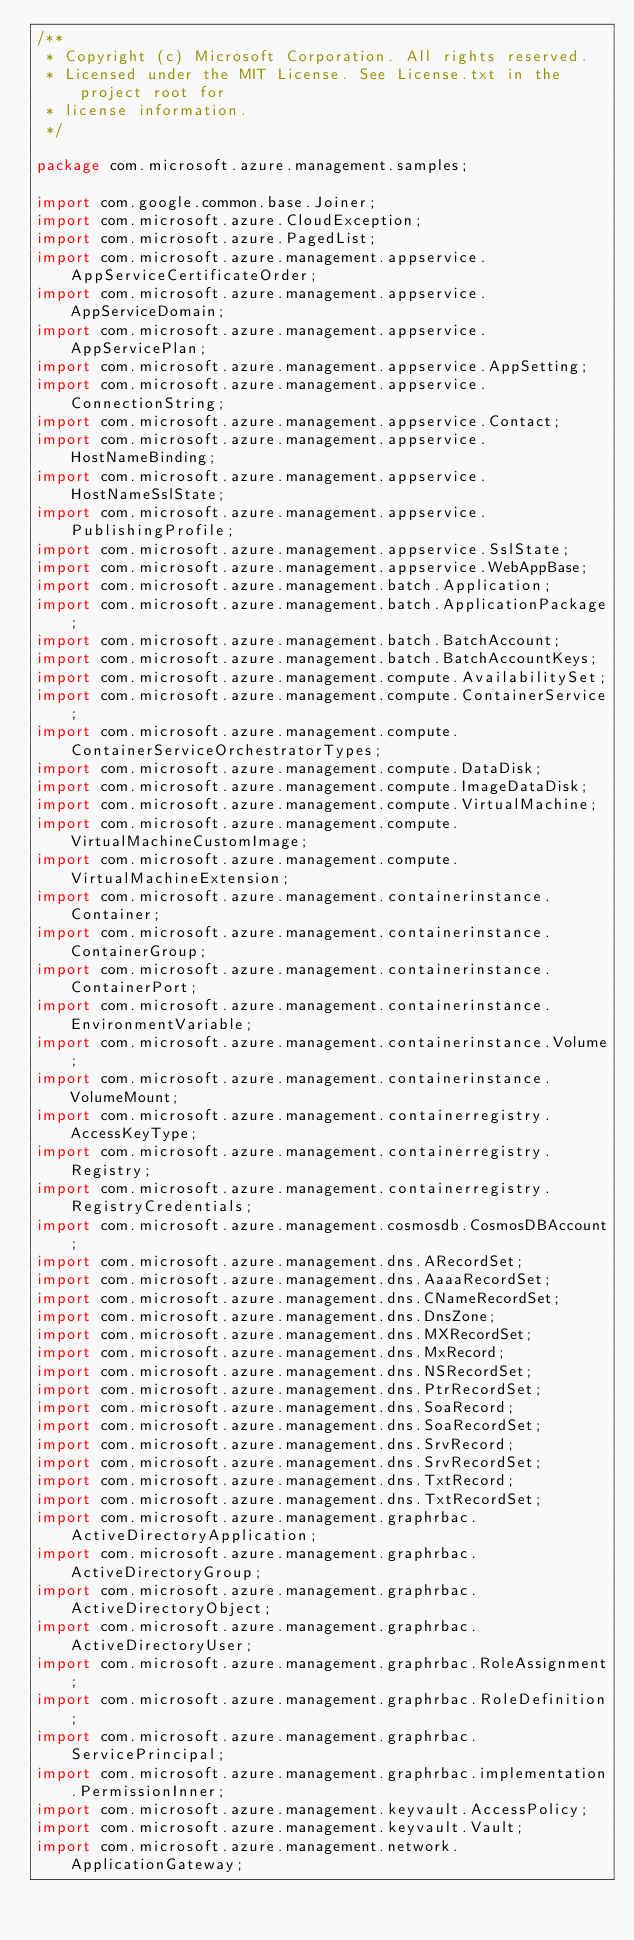<code> <loc_0><loc_0><loc_500><loc_500><_Java_>/**
 * Copyright (c) Microsoft Corporation. All rights reserved.
 * Licensed under the MIT License. See License.txt in the project root for
 * license information.
 */

package com.microsoft.azure.management.samples;

import com.google.common.base.Joiner;
import com.microsoft.azure.CloudException;
import com.microsoft.azure.PagedList;
import com.microsoft.azure.management.appservice.AppServiceCertificateOrder;
import com.microsoft.azure.management.appservice.AppServiceDomain;
import com.microsoft.azure.management.appservice.AppServicePlan;
import com.microsoft.azure.management.appservice.AppSetting;
import com.microsoft.azure.management.appservice.ConnectionString;
import com.microsoft.azure.management.appservice.Contact;
import com.microsoft.azure.management.appservice.HostNameBinding;
import com.microsoft.azure.management.appservice.HostNameSslState;
import com.microsoft.azure.management.appservice.PublishingProfile;
import com.microsoft.azure.management.appservice.SslState;
import com.microsoft.azure.management.appservice.WebAppBase;
import com.microsoft.azure.management.batch.Application;
import com.microsoft.azure.management.batch.ApplicationPackage;
import com.microsoft.azure.management.batch.BatchAccount;
import com.microsoft.azure.management.batch.BatchAccountKeys;
import com.microsoft.azure.management.compute.AvailabilitySet;
import com.microsoft.azure.management.compute.ContainerService;
import com.microsoft.azure.management.compute.ContainerServiceOrchestratorTypes;
import com.microsoft.azure.management.compute.DataDisk;
import com.microsoft.azure.management.compute.ImageDataDisk;
import com.microsoft.azure.management.compute.VirtualMachine;
import com.microsoft.azure.management.compute.VirtualMachineCustomImage;
import com.microsoft.azure.management.compute.VirtualMachineExtension;
import com.microsoft.azure.management.containerinstance.Container;
import com.microsoft.azure.management.containerinstance.ContainerGroup;
import com.microsoft.azure.management.containerinstance.ContainerPort;
import com.microsoft.azure.management.containerinstance.EnvironmentVariable;
import com.microsoft.azure.management.containerinstance.Volume;
import com.microsoft.azure.management.containerinstance.VolumeMount;
import com.microsoft.azure.management.containerregistry.AccessKeyType;
import com.microsoft.azure.management.containerregistry.Registry;
import com.microsoft.azure.management.containerregistry.RegistryCredentials;
import com.microsoft.azure.management.cosmosdb.CosmosDBAccount;
import com.microsoft.azure.management.dns.ARecordSet;
import com.microsoft.azure.management.dns.AaaaRecordSet;
import com.microsoft.azure.management.dns.CNameRecordSet;
import com.microsoft.azure.management.dns.DnsZone;
import com.microsoft.azure.management.dns.MXRecordSet;
import com.microsoft.azure.management.dns.MxRecord;
import com.microsoft.azure.management.dns.NSRecordSet;
import com.microsoft.azure.management.dns.PtrRecordSet;
import com.microsoft.azure.management.dns.SoaRecord;
import com.microsoft.azure.management.dns.SoaRecordSet;
import com.microsoft.azure.management.dns.SrvRecord;
import com.microsoft.azure.management.dns.SrvRecordSet;
import com.microsoft.azure.management.dns.TxtRecord;
import com.microsoft.azure.management.dns.TxtRecordSet;
import com.microsoft.azure.management.graphrbac.ActiveDirectoryApplication;
import com.microsoft.azure.management.graphrbac.ActiveDirectoryGroup;
import com.microsoft.azure.management.graphrbac.ActiveDirectoryObject;
import com.microsoft.azure.management.graphrbac.ActiveDirectoryUser;
import com.microsoft.azure.management.graphrbac.RoleAssignment;
import com.microsoft.azure.management.graphrbac.RoleDefinition;
import com.microsoft.azure.management.graphrbac.ServicePrincipal;
import com.microsoft.azure.management.graphrbac.implementation.PermissionInner;
import com.microsoft.azure.management.keyvault.AccessPolicy;
import com.microsoft.azure.management.keyvault.Vault;
import com.microsoft.azure.management.network.ApplicationGateway;</code> 